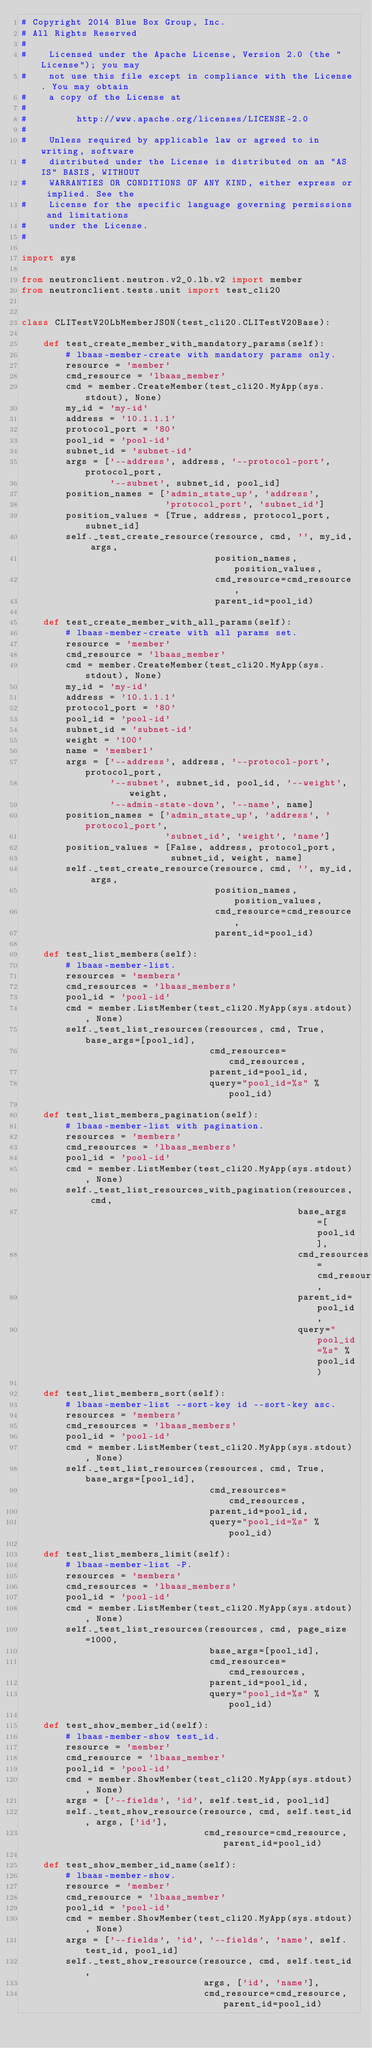Convert code to text. <code><loc_0><loc_0><loc_500><loc_500><_Python_># Copyright 2014 Blue Box Group, Inc.
# All Rights Reserved
#
#    Licensed under the Apache License, Version 2.0 (the "License"); you may
#    not use this file except in compliance with the License. You may obtain
#    a copy of the License at
#
#         http://www.apache.org/licenses/LICENSE-2.0
#
#    Unless required by applicable law or agreed to in writing, software
#    distributed under the License is distributed on an "AS IS" BASIS, WITHOUT
#    WARRANTIES OR CONDITIONS OF ANY KIND, either express or implied. See the
#    License for the specific language governing permissions and limitations
#    under the License.
#

import sys

from neutronclient.neutron.v2_0.lb.v2 import member
from neutronclient.tests.unit import test_cli20


class CLITestV20LbMemberJSON(test_cli20.CLITestV20Base):

    def test_create_member_with_mandatory_params(self):
        # lbaas-member-create with mandatory params only.
        resource = 'member'
        cmd_resource = 'lbaas_member'
        cmd = member.CreateMember(test_cli20.MyApp(sys.stdout), None)
        my_id = 'my-id'
        address = '10.1.1.1'
        protocol_port = '80'
        pool_id = 'pool-id'
        subnet_id = 'subnet-id'
        args = ['--address', address, '--protocol-port', protocol_port,
                '--subnet', subnet_id, pool_id]
        position_names = ['admin_state_up', 'address',
                          'protocol_port', 'subnet_id']
        position_values = [True, address, protocol_port, subnet_id]
        self._test_create_resource(resource, cmd, '', my_id, args,
                                   position_names, position_values,
                                   cmd_resource=cmd_resource,
                                   parent_id=pool_id)

    def test_create_member_with_all_params(self):
        # lbaas-member-create with all params set.
        resource = 'member'
        cmd_resource = 'lbaas_member'
        cmd = member.CreateMember(test_cli20.MyApp(sys.stdout), None)
        my_id = 'my-id'
        address = '10.1.1.1'
        protocol_port = '80'
        pool_id = 'pool-id'
        subnet_id = 'subnet-id'
        weight = '100'
        name = 'member1'
        args = ['--address', address, '--protocol-port', protocol_port,
                '--subnet', subnet_id, pool_id, '--weight', weight,
                '--admin-state-down', '--name', name]
        position_names = ['admin_state_up', 'address', 'protocol_port',
                          'subnet_id', 'weight', 'name']
        position_values = [False, address, protocol_port,
                           subnet_id, weight, name]
        self._test_create_resource(resource, cmd, '', my_id, args,
                                   position_names, position_values,
                                   cmd_resource=cmd_resource,
                                   parent_id=pool_id)

    def test_list_members(self):
        # lbaas-member-list.
        resources = 'members'
        cmd_resources = 'lbaas_members'
        pool_id = 'pool-id'
        cmd = member.ListMember(test_cli20.MyApp(sys.stdout), None)
        self._test_list_resources(resources, cmd, True, base_args=[pool_id],
                                  cmd_resources=cmd_resources,
                                  parent_id=pool_id,
                                  query="pool_id=%s" % pool_id)

    def test_list_members_pagination(self):
        # lbaas-member-list with pagination.
        resources = 'members'
        cmd_resources = 'lbaas_members'
        pool_id = 'pool-id'
        cmd = member.ListMember(test_cli20.MyApp(sys.stdout), None)
        self._test_list_resources_with_pagination(resources, cmd,
                                                  base_args=[pool_id],
                                                  cmd_resources=cmd_resources,
                                                  parent_id=pool_id,
                                                  query="pool_id=%s" % pool_id)

    def test_list_members_sort(self):
        # lbaas-member-list --sort-key id --sort-key asc.
        resources = 'members'
        cmd_resources = 'lbaas_members'
        pool_id = 'pool-id'
        cmd = member.ListMember(test_cli20.MyApp(sys.stdout), None)
        self._test_list_resources(resources, cmd, True, base_args=[pool_id],
                                  cmd_resources=cmd_resources,
                                  parent_id=pool_id,
                                  query="pool_id=%s" % pool_id)

    def test_list_members_limit(self):
        # lbaas-member-list -P.
        resources = 'members'
        cmd_resources = 'lbaas_members'
        pool_id = 'pool-id'
        cmd = member.ListMember(test_cli20.MyApp(sys.stdout), None)
        self._test_list_resources(resources, cmd, page_size=1000,
                                  base_args=[pool_id],
                                  cmd_resources=cmd_resources,
                                  parent_id=pool_id,
                                  query="pool_id=%s" % pool_id)

    def test_show_member_id(self):
        # lbaas-member-show test_id.
        resource = 'member'
        cmd_resource = 'lbaas_member'
        pool_id = 'pool-id'
        cmd = member.ShowMember(test_cli20.MyApp(sys.stdout), None)
        args = ['--fields', 'id', self.test_id, pool_id]
        self._test_show_resource(resource, cmd, self.test_id, args, ['id'],
                                 cmd_resource=cmd_resource, parent_id=pool_id)

    def test_show_member_id_name(self):
        # lbaas-member-show.
        resource = 'member'
        cmd_resource = 'lbaas_member'
        pool_id = 'pool-id'
        cmd = member.ShowMember(test_cli20.MyApp(sys.stdout), None)
        args = ['--fields', 'id', '--fields', 'name', self.test_id, pool_id]
        self._test_show_resource(resource, cmd, self.test_id,
                                 args, ['id', 'name'],
                                 cmd_resource=cmd_resource, parent_id=pool_id)
</code> 